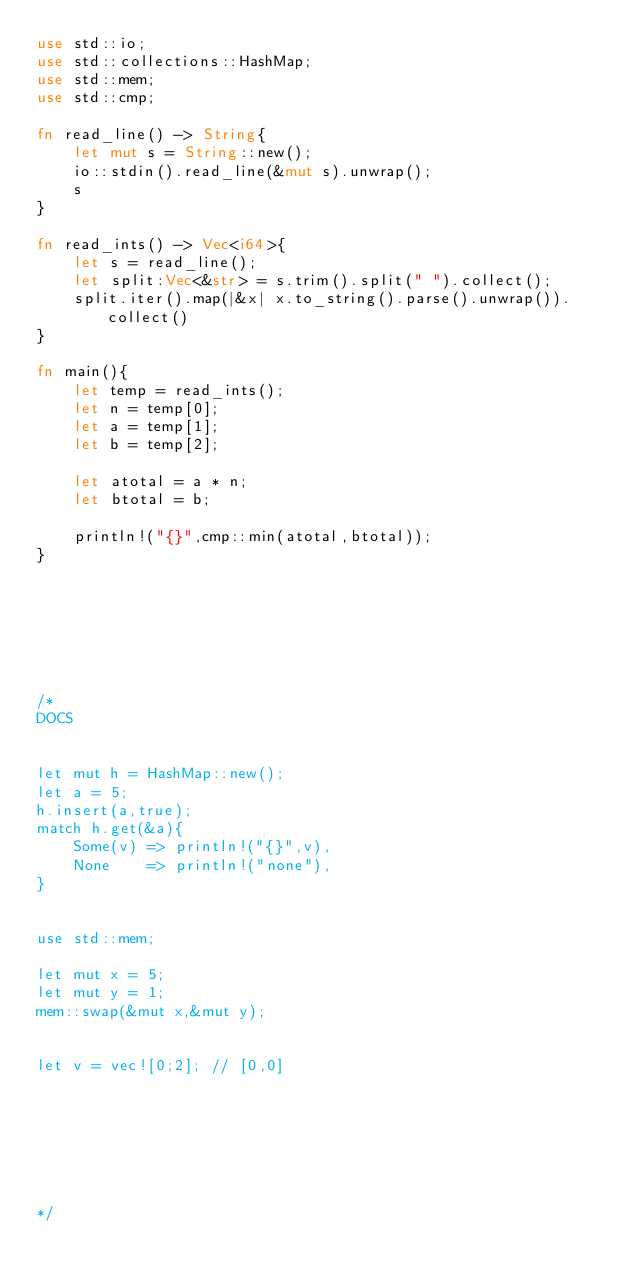Convert code to text. <code><loc_0><loc_0><loc_500><loc_500><_Rust_>use std::io;
use std::collections::HashMap;
use std::mem;
use std::cmp;

fn read_line() -> String{
    let mut s = String::new();
    io::stdin().read_line(&mut s).unwrap();
    s
}

fn read_ints() -> Vec<i64>{
    let s = read_line();
    let split:Vec<&str> = s.trim().split(" ").collect();
    split.iter().map(|&x| x.to_string().parse().unwrap()).collect()
}

fn main(){
    let temp = read_ints();
    let n = temp[0];
    let a = temp[1];
    let b = temp[2];
    
    let atotal = a * n;
    let btotal = b;
    
    println!("{}",cmp::min(atotal,btotal));
}







/*
DOCS


let mut h = HashMap::new();
let a = 5;
h.insert(a,true);
match h.get(&a){
    Some(v) => println!("{}",v),
    None    => println!("none"),
}


use std::mem;

let mut x = 5;
let mut y = 1;
mem::swap(&mut x,&mut y);


let v = vec![0;2]; // [0,0]







*/</code> 